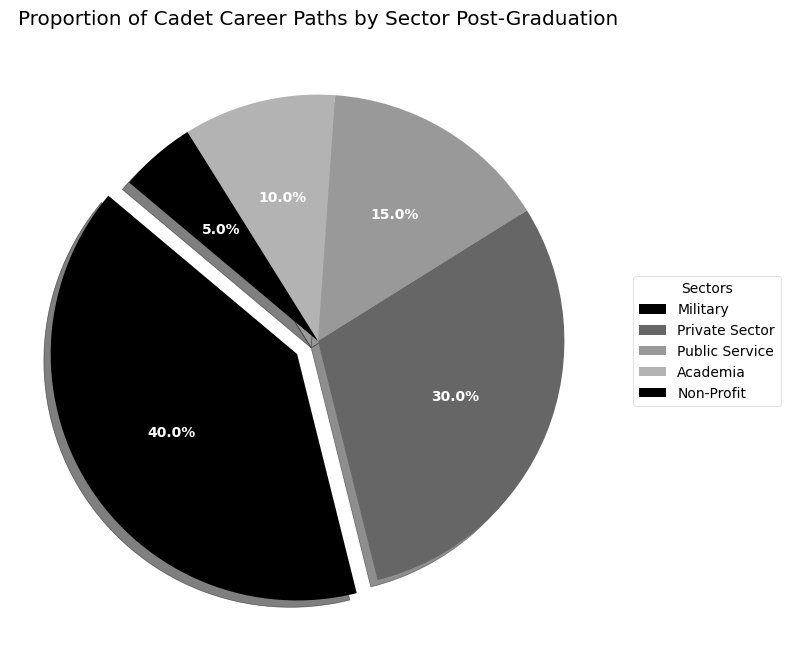Which sector has the highest proportion of cadet career paths? The pie chart indicates that the Military sector has the highest percentage, which is also visually emphasized by the exploded slice and the legend.
Answer: Military What is the combined proportion of cadets in Public Service and Non-Profit sectors? The proportion of cadets in Public Service is 15% and in Non-Profit is 5%. Adding these together, 15% + 5% = 20%.
Answer: 20% Compare the proportions of cadets entering the Private Sector and Academia. Which is larger and by how much? The Private Sector has 30% and Academia has 10%. The Private Sector proportion is larger, with a difference of 30% - 10% = 20%.
Answer: Private Sector by 20% If you exclude the Military sector, what percentage of cadets go into other sectors combined? Excluding the Military sector, the remaining sectors are Private Sector (30%), Public Service (15%), Academia (10%), and Non-Profit (5%). Their combined percentage is 30% + 15% + 10% + 5% = 60%.
Answer: 60% What is the smallest sector in terms of cadet career paths, and what is its proportion? The pie chart shows that the Non-Profit sector has the smallest proportion, which is also listed in the legend. Its proportion is 5%.
Answer: Non-Profit, 5% What is the visual indication used to highlight the largest sector in the pie chart? The largest sector, Military, is visually emphasized by the exploded slice, which creates a gap between it and the rest of the chart.
Answer: Exploded slice How do the proportions of cadets in the Military sector compare to those in Academia and Non-Profit combined? Military has 40%. Academia and Non-Profit combined equal 10% + 5% = 15%. Comparing these, the Military proportion is 40%, which is greater than the 15% combined total of Academia and Non-Profit.
Answer: Military is larger What proportion of cadets pursue careers outside the Private Sector and Military sectors combined? The combined percentage of cadets in the Private Sector (30%) and Military (40%) is 70%. Therefore, the remaining cadets in other sectors account for 100% - 70% = 30%.
Answer: 30% Determine the sum of the proportions for the top three sectors by size. The top three sectors are Military (40%), Private Sector (30%), and Public Service (15%). Their combined total is 40% + 30% + 15% = 85%.
Answer: 85% What proportion of cadets choose paths in either the Military or Public Service? The Military sector has 40% and Public Service has 15%. Their combined total is 40% + 15% = 55%.
Answer: 55% 